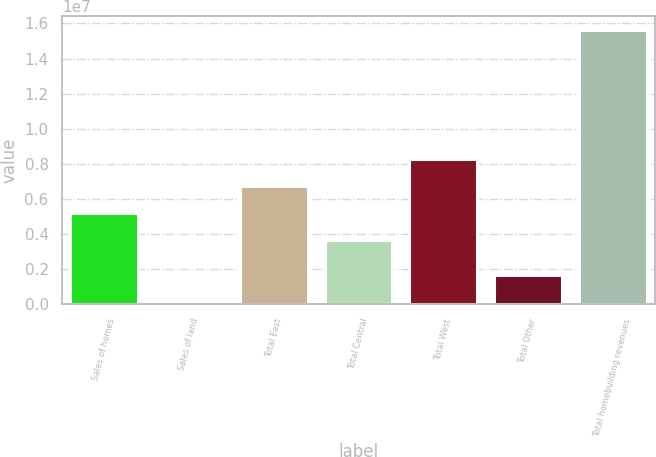Convert chart to OTSL. <chart><loc_0><loc_0><loc_500><loc_500><bar_chart><fcel>Sales of homes<fcel>Sales of land<fcel>Total East<fcel>Total Central<fcel>Total West<fcel>Total Other<fcel>Total homebuilding revenues<nl><fcel>5.1986e+06<fcel>129297<fcel>6.74797e+06<fcel>3.64922e+06<fcel>8.29734e+06<fcel>1.67867e+06<fcel>1.5623e+07<nl></chart> 